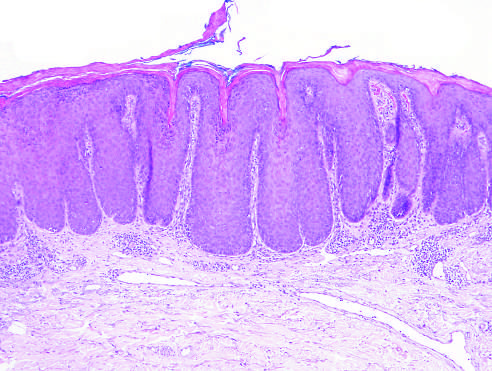re this diagrammatic representation of four normal motor units present?
Answer the question using a single word or phrase. No 